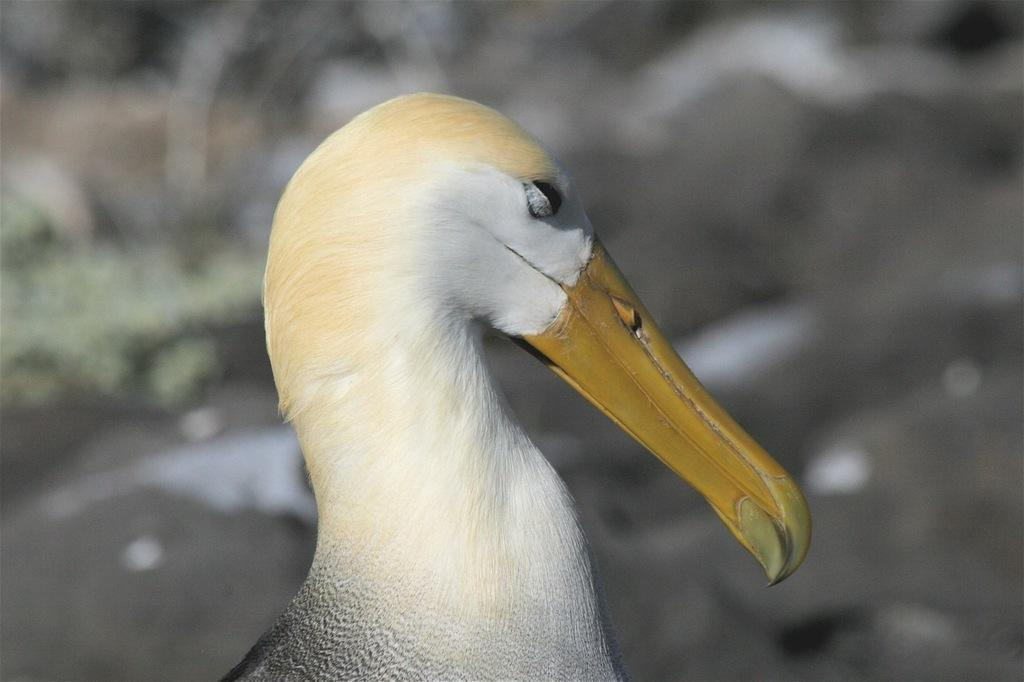Where was the image taken? The image was taken outdoors. Can you describe the background of the image? The background of the image is blurred and gray in color. What is the main subject of the image? There is a bird in the middle of the image. What is unique about the bird's appearance? The bird has a long beak. What is the opinion of the hospital regarding the bird's long beak in the image? There is no hospital present in the image, nor is there any indication that the bird's long beak is related to a hospital or its opinion. 